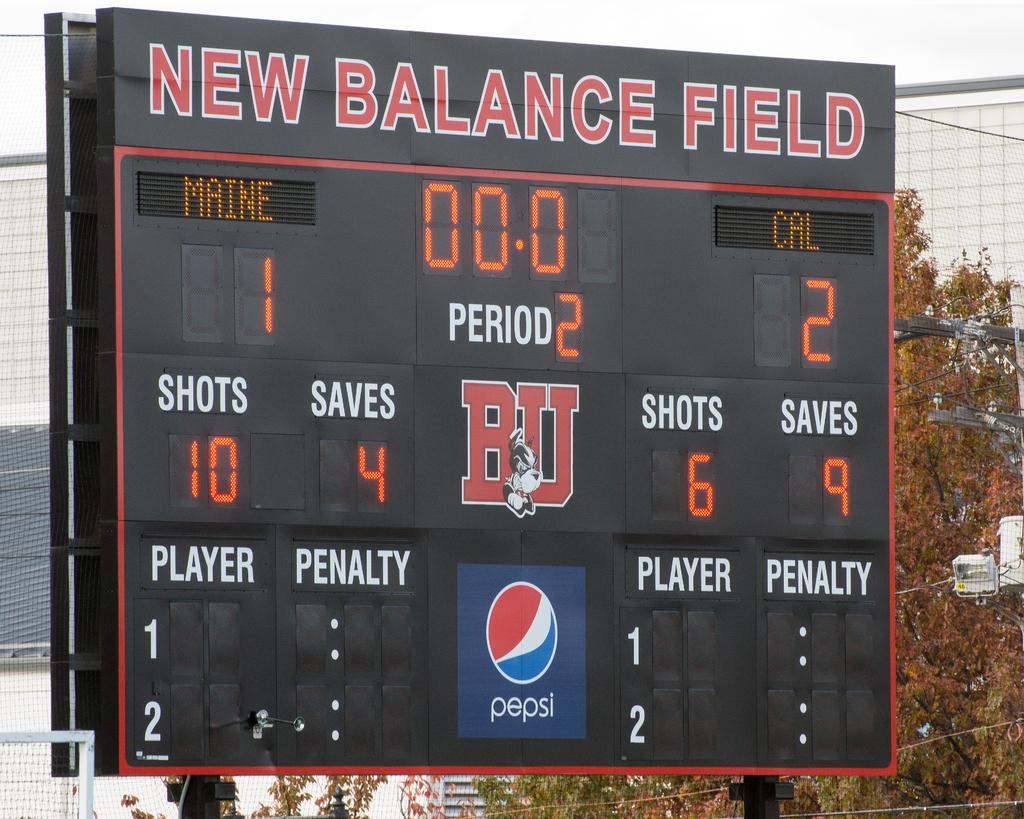<image>
Give a short and clear explanation of the subsequent image. A scoreboard at New Balance Field shows Maine is losing by one point 